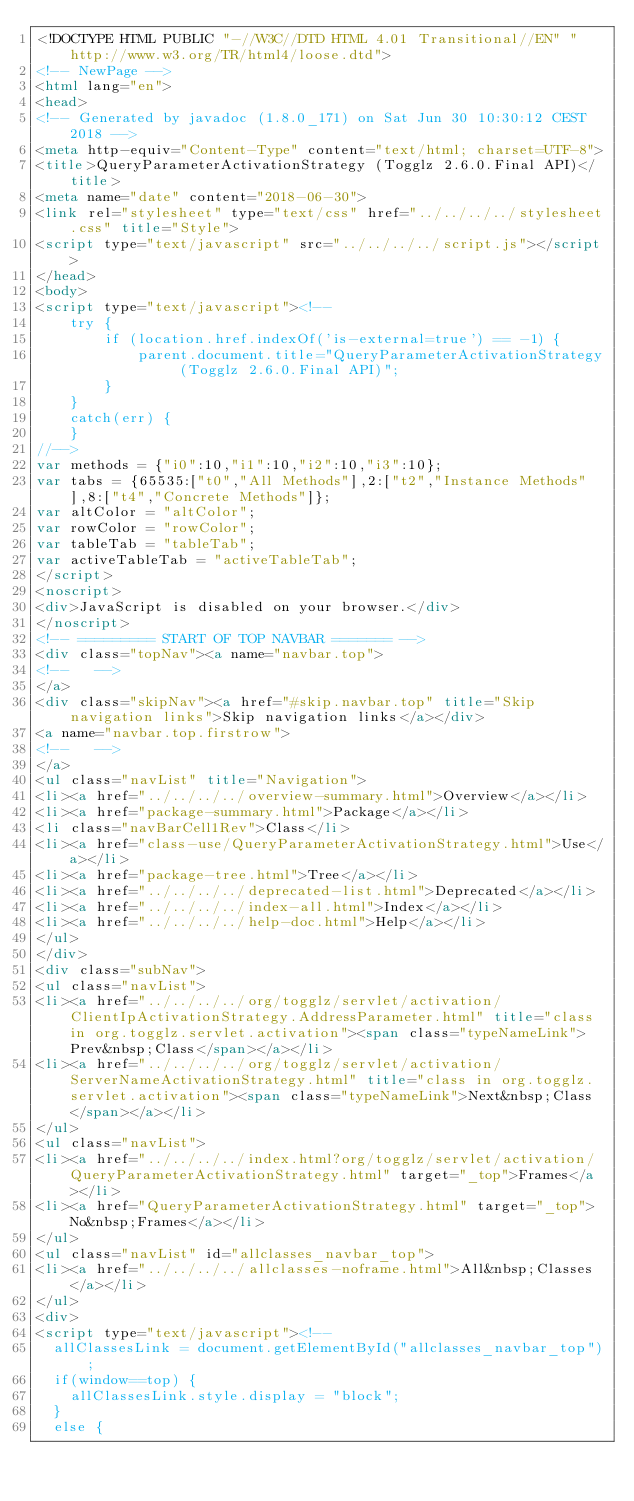<code> <loc_0><loc_0><loc_500><loc_500><_HTML_><!DOCTYPE HTML PUBLIC "-//W3C//DTD HTML 4.01 Transitional//EN" "http://www.w3.org/TR/html4/loose.dtd">
<!-- NewPage -->
<html lang="en">
<head>
<!-- Generated by javadoc (1.8.0_171) on Sat Jun 30 10:30:12 CEST 2018 -->
<meta http-equiv="Content-Type" content="text/html; charset=UTF-8">
<title>QueryParameterActivationStrategy (Togglz 2.6.0.Final API)</title>
<meta name="date" content="2018-06-30">
<link rel="stylesheet" type="text/css" href="../../../../stylesheet.css" title="Style">
<script type="text/javascript" src="../../../../script.js"></script>
</head>
<body>
<script type="text/javascript"><!--
    try {
        if (location.href.indexOf('is-external=true') == -1) {
            parent.document.title="QueryParameterActivationStrategy (Togglz 2.6.0.Final API)";
        }
    }
    catch(err) {
    }
//-->
var methods = {"i0":10,"i1":10,"i2":10,"i3":10};
var tabs = {65535:["t0","All Methods"],2:["t2","Instance Methods"],8:["t4","Concrete Methods"]};
var altColor = "altColor";
var rowColor = "rowColor";
var tableTab = "tableTab";
var activeTableTab = "activeTableTab";
</script>
<noscript>
<div>JavaScript is disabled on your browser.</div>
</noscript>
<!-- ========= START OF TOP NAVBAR ======= -->
<div class="topNav"><a name="navbar.top">
<!--   -->
</a>
<div class="skipNav"><a href="#skip.navbar.top" title="Skip navigation links">Skip navigation links</a></div>
<a name="navbar.top.firstrow">
<!--   -->
</a>
<ul class="navList" title="Navigation">
<li><a href="../../../../overview-summary.html">Overview</a></li>
<li><a href="package-summary.html">Package</a></li>
<li class="navBarCell1Rev">Class</li>
<li><a href="class-use/QueryParameterActivationStrategy.html">Use</a></li>
<li><a href="package-tree.html">Tree</a></li>
<li><a href="../../../../deprecated-list.html">Deprecated</a></li>
<li><a href="../../../../index-all.html">Index</a></li>
<li><a href="../../../../help-doc.html">Help</a></li>
</ul>
</div>
<div class="subNav">
<ul class="navList">
<li><a href="../../../../org/togglz/servlet/activation/ClientIpActivationStrategy.AddressParameter.html" title="class in org.togglz.servlet.activation"><span class="typeNameLink">Prev&nbsp;Class</span></a></li>
<li><a href="../../../../org/togglz/servlet/activation/ServerNameActivationStrategy.html" title="class in org.togglz.servlet.activation"><span class="typeNameLink">Next&nbsp;Class</span></a></li>
</ul>
<ul class="navList">
<li><a href="../../../../index.html?org/togglz/servlet/activation/QueryParameterActivationStrategy.html" target="_top">Frames</a></li>
<li><a href="QueryParameterActivationStrategy.html" target="_top">No&nbsp;Frames</a></li>
</ul>
<ul class="navList" id="allclasses_navbar_top">
<li><a href="../../../../allclasses-noframe.html">All&nbsp;Classes</a></li>
</ul>
<div>
<script type="text/javascript"><!--
  allClassesLink = document.getElementById("allclasses_navbar_top");
  if(window==top) {
    allClassesLink.style.display = "block";
  }
  else {</code> 